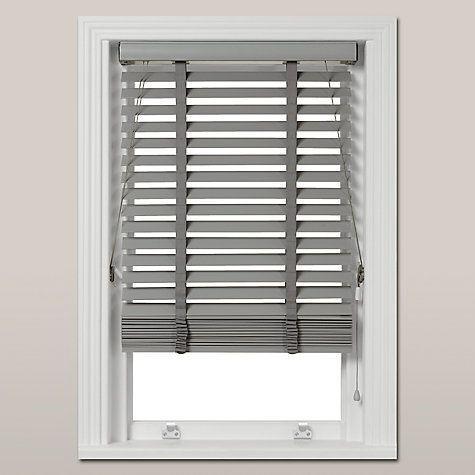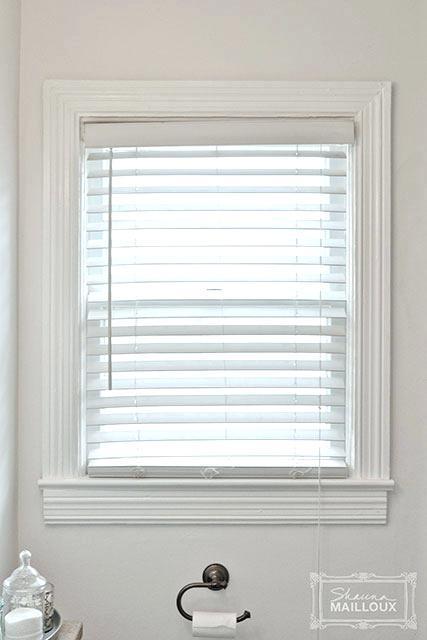The first image is the image on the left, the second image is the image on the right. Assess this claim about the two images: "There are two blinds.". Correct or not? Answer yes or no. Yes. The first image is the image on the left, the second image is the image on the right. Analyze the images presented: Is the assertion "The blinds in a room above a bathtub let in the light in the image on the left." valid? Answer yes or no. No. 